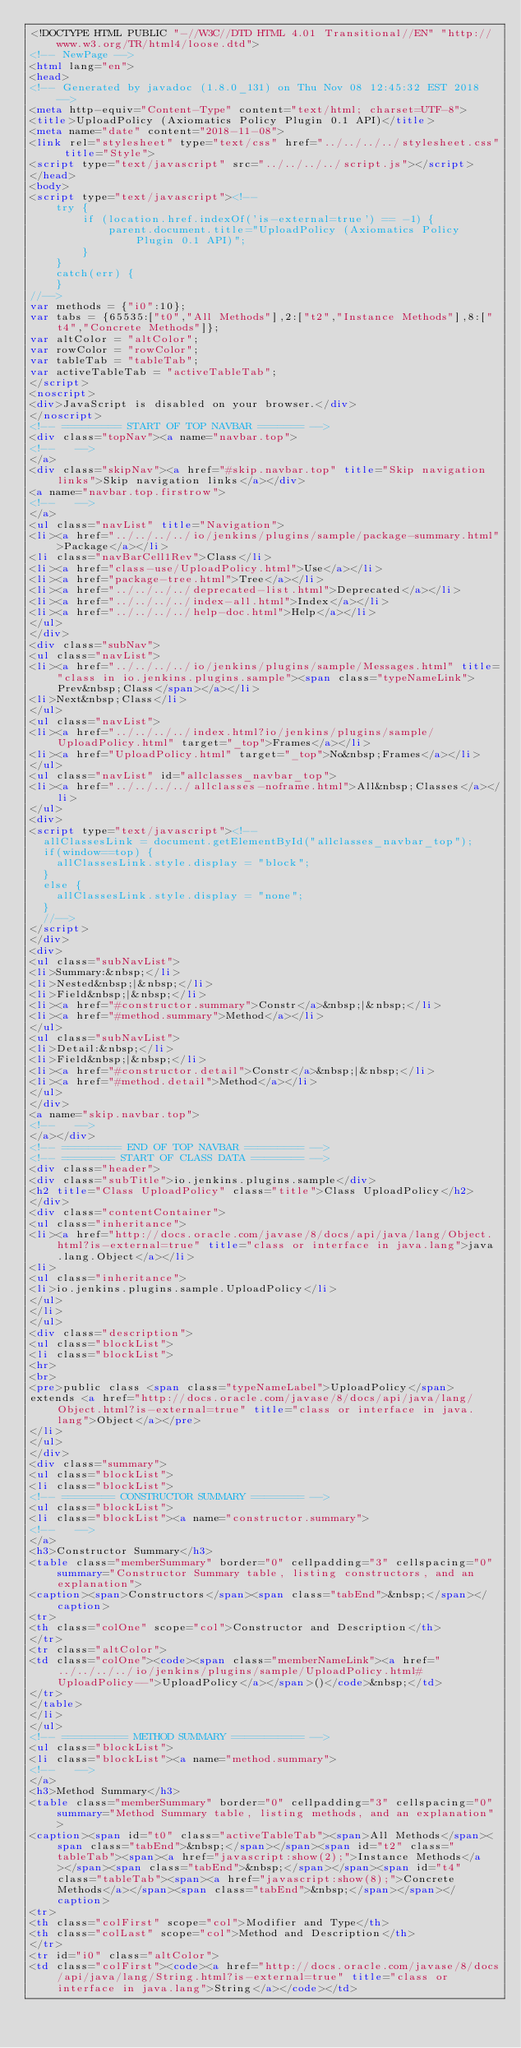Convert code to text. <code><loc_0><loc_0><loc_500><loc_500><_HTML_><!DOCTYPE HTML PUBLIC "-//W3C//DTD HTML 4.01 Transitional//EN" "http://www.w3.org/TR/html4/loose.dtd">
<!-- NewPage -->
<html lang="en">
<head>
<!-- Generated by javadoc (1.8.0_131) on Thu Nov 08 12:45:32 EST 2018 -->
<meta http-equiv="Content-Type" content="text/html; charset=UTF-8">
<title>UploadPolicy (Axiomatics Policy Plugin 0.1 API)</title>
<meta name="date" content="2018-11-08">
<link rel="stylesheet" type="text/css" href="../../../../stylesheet.css" title="Style">
<script type="text/javascript" src="../../../../script.js"></script>
</head>
<body>
<script type="text/javascript"><!--
    try {
        if (location.href.indexOf('is-external=true') == -1) {
            parent.document.title="UploadPolicy (Axiomatics Policy Plugin 0.1 API)";
        }
    }
    catch(err) {
    }
//-->
var methods = {"i0":10};
var tabs = {65535:["t0","All Methods"],2:["t2","Instance Methods"],8:["t4","Concrete Methods"]};
var altColor = "altColor";
var rowColor = "rowColor";
var tableTab = "tableTab";
var activeTableTab = "activeTableTab";
</script>
<noscript>
<div>JavaScript is disabled on your browser.</div>
</noscript>
<!-- ========= START OF TOP NAVBAR ======= -->
<div class="topNav"><a name="navbar.top">
<!--   -->
</a>
<div class="skipNav"><a href="#skip.navbar.top" title="Skip navigation links">Skip navigation links</a></div>
<a name="navbar.top.firstrow">
<!--   -->
</a>
<ul class="navList" title="Navigation">
<li><a href="../../../../io/jenkins/plugins/sample/package-summary.html">Package</a></li>
<li class="navBarCell1Rev">Class</li>
<li><a href="class-use/UploadPolicy.html">Use</a></li>
<li><a href="package-tree.html">Tree</a></li>
<li><a href="../../../../deprecated-list.html">Deprecated</a></li>
<li><a href="../../../../index-all.html">Index</a></li>
<li><a href="../../../../help-doc.html">Help</a></li>
</ul>
</div>
<div class="subNav">
<ul class="navList">
<li><a href="../../../../io/jenkins/plugins/sample/Messages.html" title="class in io.jenkins.plugins.sample"><span class="typeNameLink">Prev&nbsp;Class</span></a></li>
<li>Next&nbsp;Class</li>
</ul>
<ul class="navList">
<li><a href="../../../../index.html?io/jenkins/plugins/sample/UploadPolicy.html" target="_top">Frames</a></li>
<li><a href="UploadPolicy.html" target="_top">No&nbsp;Frames</a></li>
</ul>
<ul class="navList" id="allclasses_navbar_top">
<li><a href="../../../../allclasses-noframe.html">All&nbsp;Classes</a></li>
</ul>
<div>
<script type="text/javascript"><!--
  allClassesLink = document.getElementById("allclasses_navbar_top");
  if(window==top) {
    allClassesLink.style.display = "block";
  }
  else {
    allClassesLink.style.display = "none";
  }
  //-->
</script>
</div>
<div>
<ul class="subNavList">
<li>Summary:&nbsp;</li>
<li>Nested&nbsp;|&nbsp;</li>
<li>Field&nbsp;|&nbsp;</li>
<li><a href="#constructor.summary">Constr</a>&nbsp;|&nbsp;</li>
<li><a href="#method.summary">Method</a></li>
</ul>
<ul class="subNavList">
<li>Detail:&nbsp;</li>
<li>Field&nbsp;|&nbsp;</li>
<li><a href="#constructor.detail">Constr</a>&nbsp;|&nbsp;</li>
<li><a href="#method.detail">Method</a></li>
</ul>
</div>
<a name="skip.navbar.top">
<!--   -->
</a></div>
<!-- ========= END OF TOP NAVBAR ========= -->
<!-- ======== START OF CLASS DATA ======== -->
<div class="header">
<div class="subTitle">io.jenkins.plugins.sample</div>
<h2 title="Class UploadPolicy" class="title">Class UploadPolicy</h2>
</div>
<div class="contentContainer">
<ul class="inheritance">
<li><a href="http://docs.oracle.com/javase/8/docs/api/java/lang/Object.html?is-external=true" title="class or interface in java.lang">java.lang.Object</a></li>
<li>
<ul class="inheritance">
<li>io.jenkins.plugins.sample.UploadPolicy</li>
</ul>
</li>
</ul>
<div class="description">
<ul class="blockList">
<li class="blockList">
<hr>
<br>
<pre>public class <span class="typeNameLabel">UploadPolicy</span>
extends <a href="http://docs.oracle.com/javase/8/docs/api/java/lang/Object.html?is-external=true" title="class or interface in java.lang">Object</a></pre>
</li>
</ul>
</div>
<div class="summary">
<ul class="blockList">
<li class="blockList">
<!-- ======== CONSTRUCTOR SUMMARY ======== -->
<ul class="blockList">
<li class="blockList"><a name="constructor.summary">
<!--   -->
</a>
<h3>Constructor Summary</h3>
<table class="memberSummary" border="0" cellpadding="3" cellspacing="0" summary="Constructor Summary table, listing constructors, and an explanation">
<caption><span>Constructors</span><span class="tabEnd">&nbsp;</span></caption>
<tr>
<th class="colOne" scope="col">Constructor and Description</th>
</tr>
<tr class="altColor">
<td class="colOne"><code><span class="memberNameLink"><a href="../../../../io/jenkins/plugins/sample/UploadPolicy.html#UploadPolicy--">UploadPolicy</a></span>()</code>&nbsp;</td>
</tr>
</table>
</li>
</ul>
<!-- ========== METHOD SUMMARY =========== -->
<ul class="blockList">
<li class="blockList"><a name="method.summary">
<!--   -->
</a>
<h3>Method Summary</h3>
<table class="memberSummary" border="0" cellpadding="3" cellspacing="0" summary="Method Summary table, listing methods, and an explanation">
<caption><span id="t0" class="activeTableTab"><span>All Methods</span><span class="tabEnd">&nbsp;</span></span><span id="t2" class="tableTab"><span><a href="javascript:show(2);">Instance Methods</a></span><span class="tabEnd">&nbsp;</span></span><span id="t4" class="tableTab"><span><a href="javascript:show(8);">Concrete Methods</a></span><span class="tabEnd">&nbsp;</span></span></caption>
<tr>
<th class="colFirst" scope="col">Modifier and Type</th>
<th class="colLast" scope="col">Method and Description</th>
</tr>
<tr id="i0" class="altColor">
<td class="colFirst"><code><a href="http://docs.oracle.com/javase/8/docs/api/java/lang/String.html?is-external=true" title="class or interface in java.lang">String</a></code></td></code> 